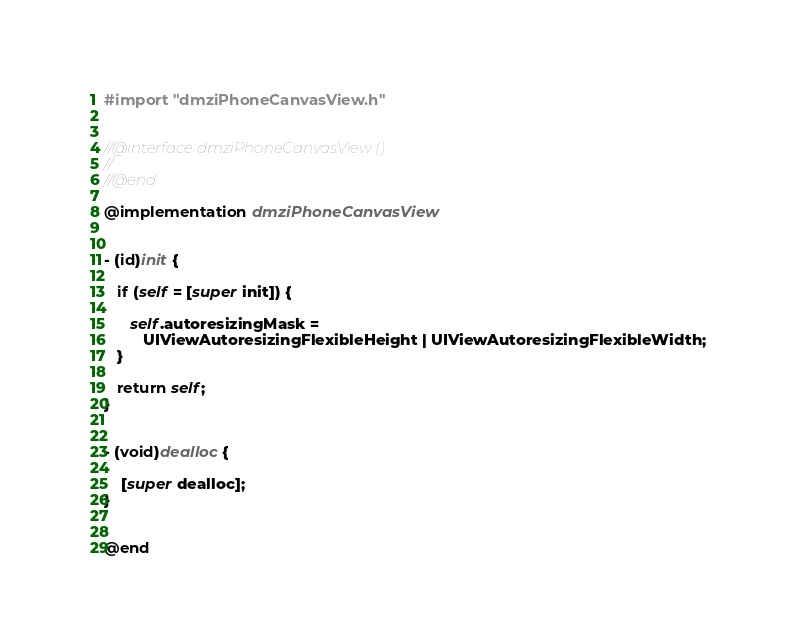<code> <loc_0><loc_0><loc_500><loc_500><_ObjectiveC_>#import "dmziPhoneCanvasView.h"


//@interface dmziPhoneCanvasView ()
//
//@end

@implementation dmziPhoneCanvasView


- (id)init {
     
   if (self = [super init]) {
      
      self.autoresizingMask =
         UIViewAutoresizingFlexibleHeight | UIViewAutoresizingFlexibleWidth;
   }
   
   return self;
}


- (void)dealloc {

	[super dealloc];
}


@end
</code> 